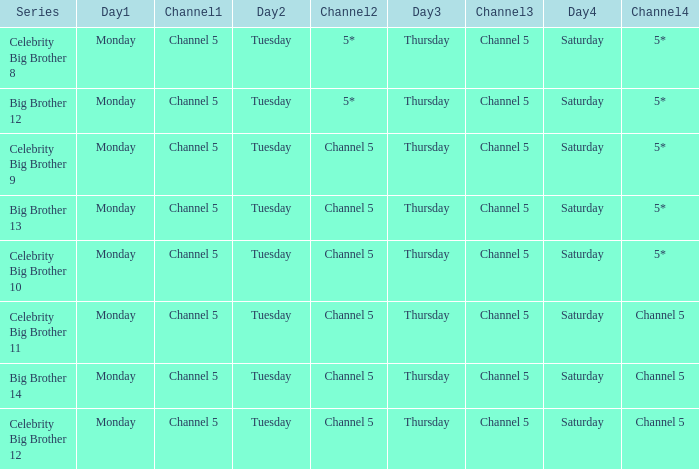Would you be able to parse every entry in this table? {'header': ['Series', 'Day1', 'Channel1', 'Day2', 'Channel2', 'Day3', 'Channel3', 'Day4', 'Channel4'], 'rows': [['Celebrity Big Brother 8', 'Monday', 'Channel 5', 'Tuesday', '5*', 'Thursday', 'Channel 5', 'Saturday', '5*'], ['Big Brother 12', 'Monday', 'Channel 5', 'Tuesday', '5*', 'Thursday', 'Channel 5', 'Saturday', '5*'], ['Celebrity Big Brother 9', 'Monday', 'Channel 5', 'Tuesday', 'Channel 5', 'Thursday', 'Channel 5', 'Saturday', '5*'], ['Big Brother 13', 'Monday', 'Channel 5', 'Tuesday', 'Channel 5', 'Thursday', 'Channel 5', 'Saturday', '5*'], ['Celebrity Big Brother 10', 'Monday', 'Channel 5', 'Tuesday', 'Channel 5', 'Thursday', 'Channel 5', 'Saturday', '5*'], ['Celebrity Big Brother 11', 'Monday', 'Channel 5', 'Tuesday', 'Channel 5', 'Thursday', 'Channel 5', 'Saturday', 'Channel 5'], ['Big Brother 14', 'Monday', 'Channel 5', 'Tuesday', 'Channel 5', 'Thursday', 'Channel 5', 'Saturday', 'Channel 5'], ['Celebrity Big Brother 12', 'Monday', 'Channel 5', 'Tuesday', 'Channel 5', 'Thursday', 'Channel 5', 'Saturday', 'Channel 5']]} Which program is scheduled on channel 5 for saturday airings? Celebrity Big Brother 11, Big Brother 14, Celebrity Big Brother 12. 